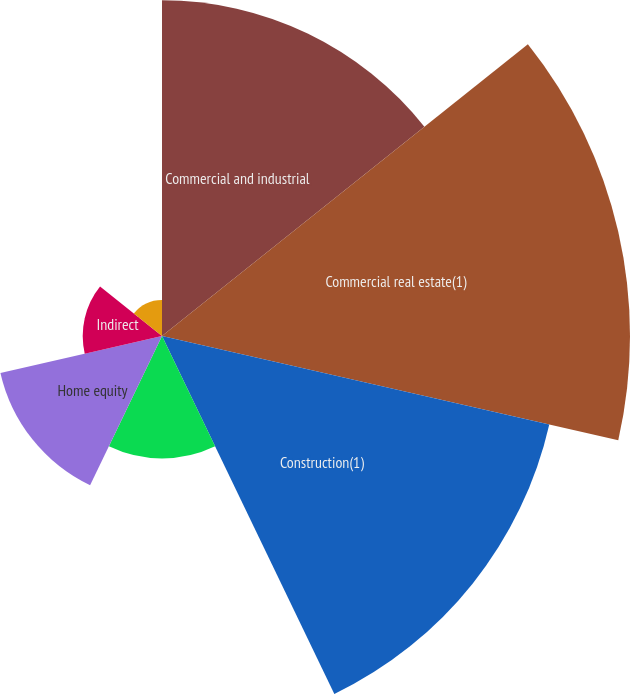<chart> <loc_0><loc_0><loc_500><loc_500><pie_chart><fcel>Commercial and industrial<fcel>Commercial real estate(1)<fcel>Construction(1)<fcel>Residential first mortgage<fcel>Home equity<fcel>Indirect<fcel>Other consumer<nl><fcel>20.92%<fcel>29.17%<fcel>24.76%<fcel>7.63%<fcel>10.33%<fcel>4.94%<fcel>2.25%<nl></chart> 